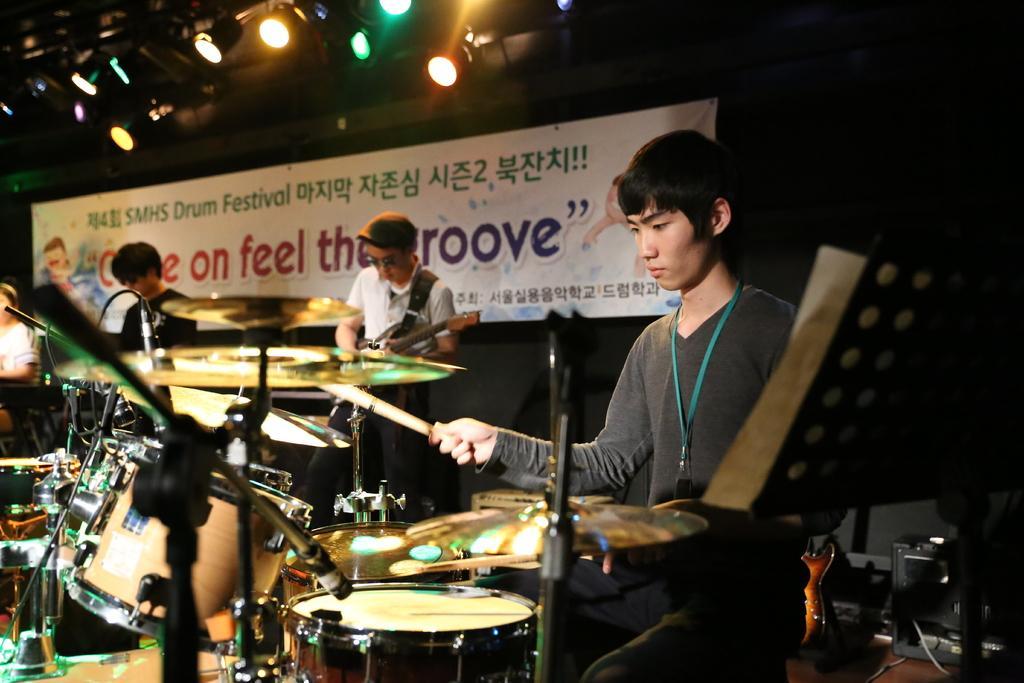Describe this image in one or two sentences. In this image we can see persons standing at the musical instruments. In the center of the image we can see person holding guitar. In the background we can see lights, wall and advertisement. 